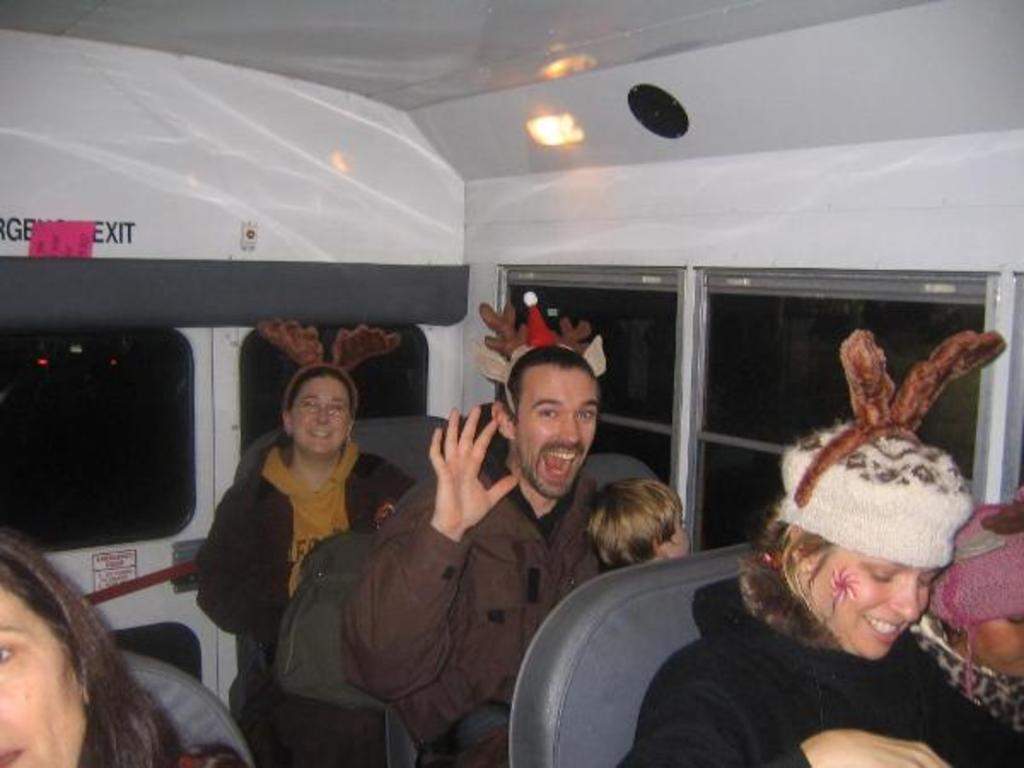What are the people in the image doing? The people in the image are sitting in a vehicle. Can you describe what is on the heads of the people in the vehicle? Unfortunately, the facts provided do not give enough information to describe what is on the heads of the people in the vehicle. What type of drug is being discussed by the people in the vehicle? There is no indication in the image that the people in the vehicle are discussing any drugs, so it's not possible to determine what, if any, drug might be discussed. 